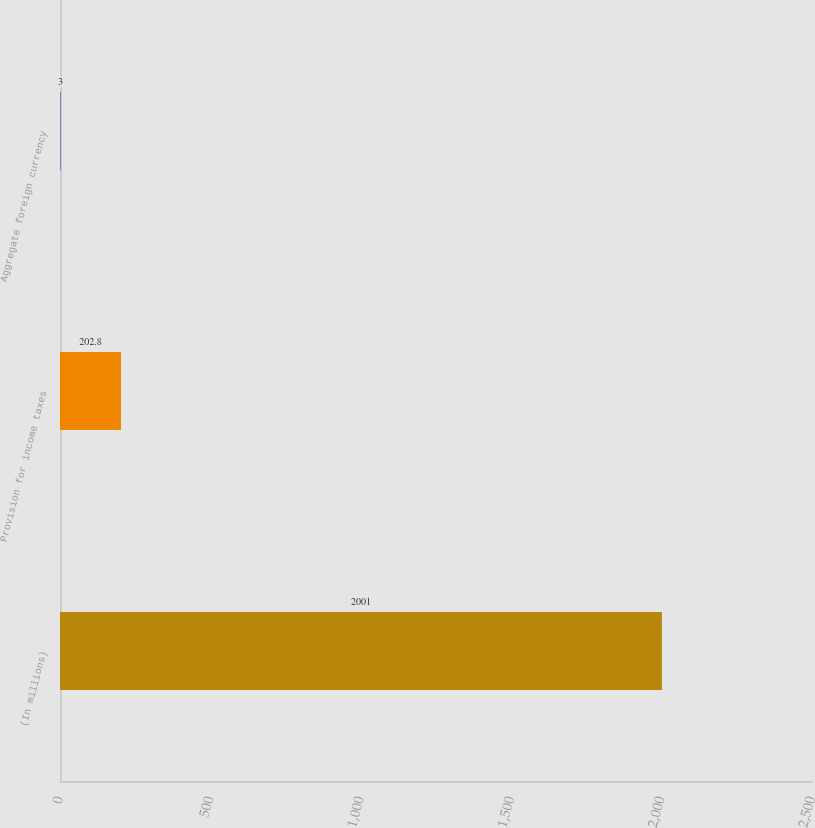Convert chart to OTSL. <chart><loc_0><loc_0><loc_500><loc_500><bar_chart><fcel>(In millions)<fcel>Provision for income taxes<fcel>Aggregate foreign currency<nl><fcel>2001<fcel>202.8<fcel>3<nl></chart> 